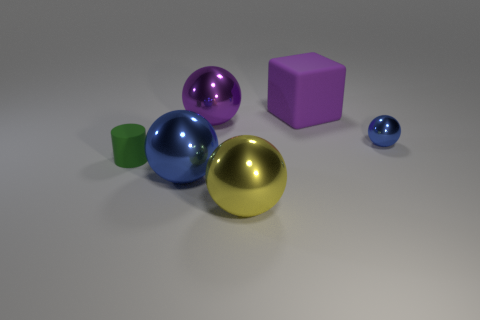There is a large metal sphere in front of the blue shiny sphere in front of the green thing; are there any big purple objects that are left of it?
Your answer should be compact. Yes. The purple rubber thing that is the same size as the yellow metallic ball is what shape?
Offer a terse response. Cube. How many tiny objects are either blue metal balls or brown rubber spheres?
Your response must be concise. 1. What color is the other thing that is the same material as the green object?
Provide a short and direct response. Purple. Does the object to the right of the big purple rubber object have the same shape as the blue object left of the purple rubber object?
Offer a very short reply. Yes. How many matte objects are small blue balls or small green things?
Offer a terse response. 1. Are there any other things that are the same shape as the purple matte object?
Your answer should be compact. No. What is the thing behind the purple metal object made of?
Keep it short and to the point. Rubber. Is the blue sphere that is behind the green matte thing made of the same material as the yellow ball?
Offer a very short reply. Yes. How many objects are either purple rubber things or purple objects that are in front of the cube?
Provide a short and direct response. 2. 